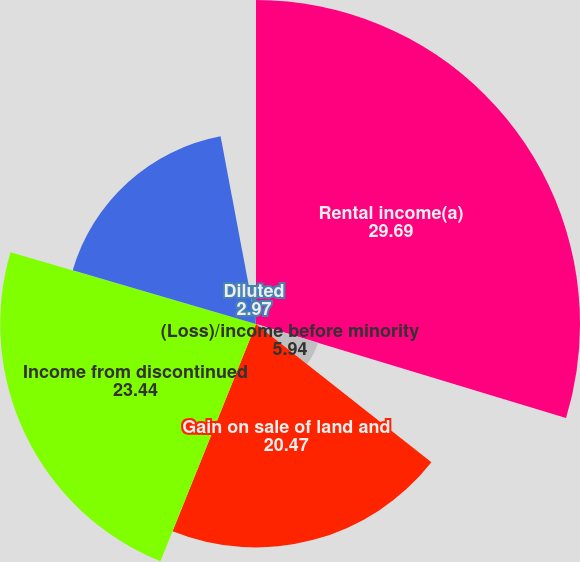Convert chart. <chart><loc_0><loc_0><loc_500><loc_500><pie_chart><fcel>Rental income(a)<fcel>(Loss)/income before minority<fcel>Gain on sale of land and<fcel>Income from discontinued<fcel>Net income available to common<fcel>Basic<fcel>Diluted<nl><fcel>29.69%<fcel>5.94%<fcel>20.47%<fcel>23.44%<fcel>17.5%<fcel>0.0%<fcel>2.97%<nl></chart> 